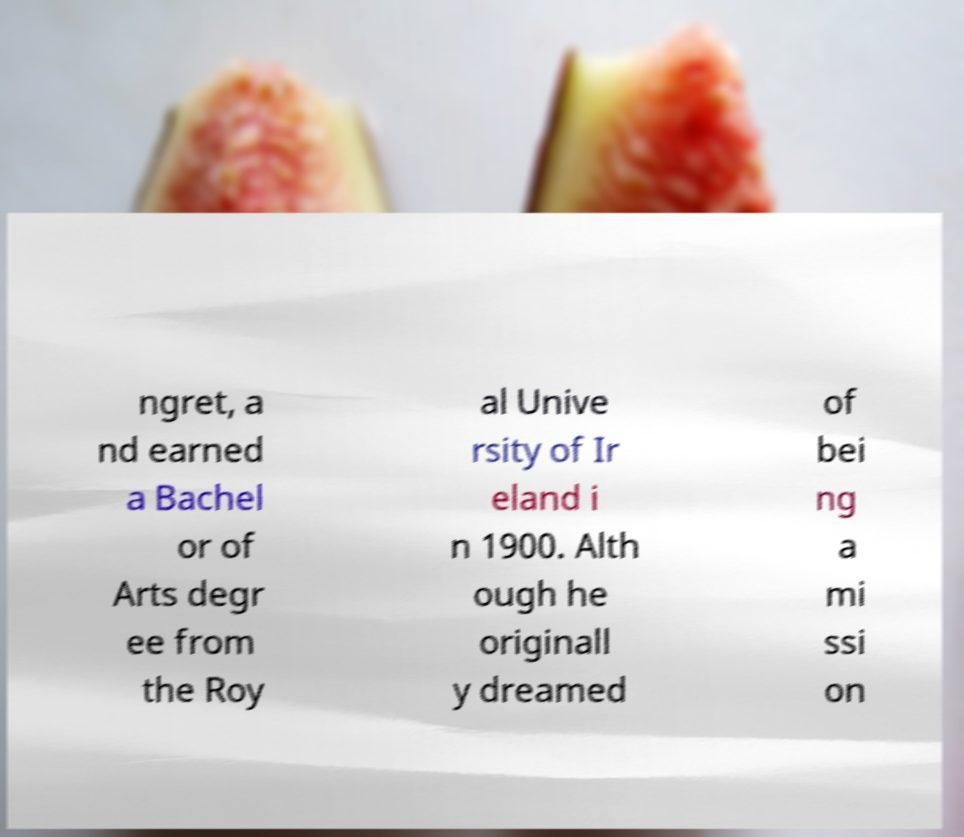Please read and relay the text visible in this image. What does it say? ngret, a nd earned a Bachel or of Arts degr ee from the Roy al Unive rsity of Ir eland i n 1900. Alth ough he originall y dreamed of bei ng a mi ssi on 